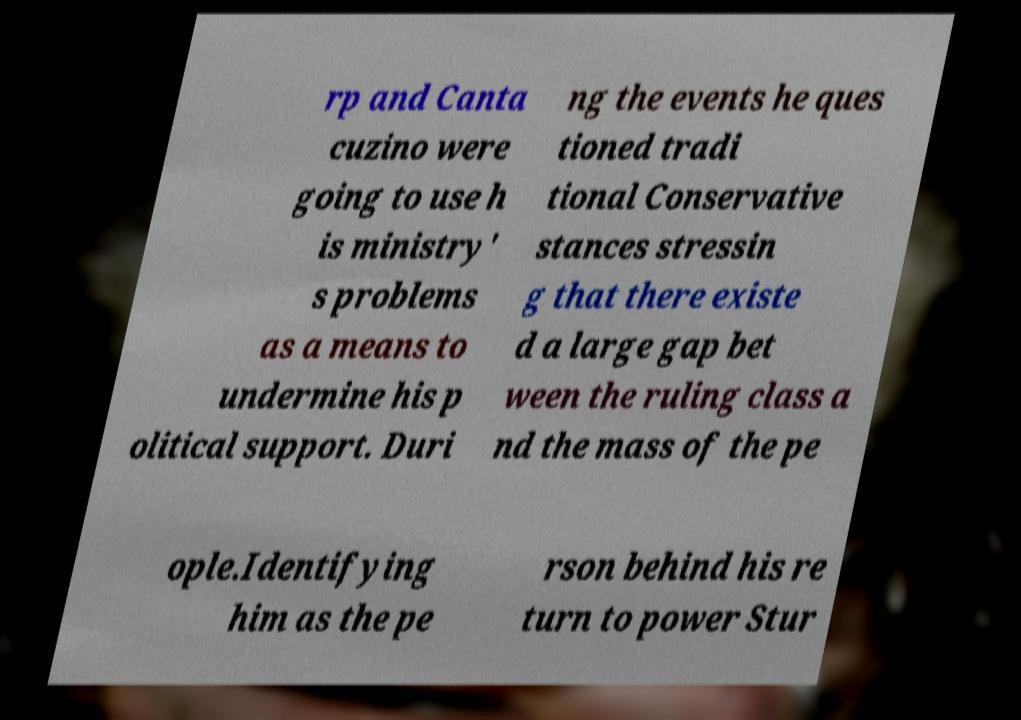What messages or text are displayed in this image? I need them in a readable, typed format. rp and Canta cuzino were going to use h is ministry' s problems as a means to undermine his p olitical support. Duri ng the events he ques tioned tradi tional Conservative stances stressin g that there existe d a large gap bet ween the ruling class a nd the mass of the pe ople.Identifying him as the pe rson behind his re turn to power Stur 